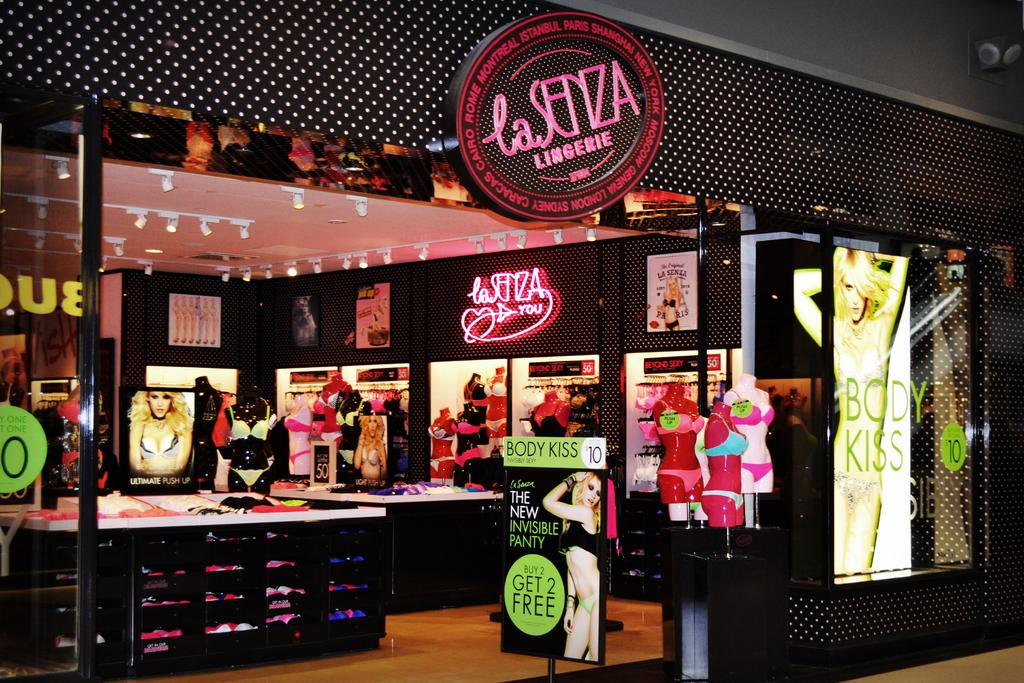What type of location is depicted in the image? The image appears to be a shopping mall. What type of items can be seen in the image? There are clothes visible in the image. What is attached to the roof in the image? Lights are fixed to the roof in the image. What surface is visible in the image? There is a floor in the image. What type of hand can be seen holding produce in the image? There is no hand or produce present in the image; it depicts a shopping mall with clothes and lights. 